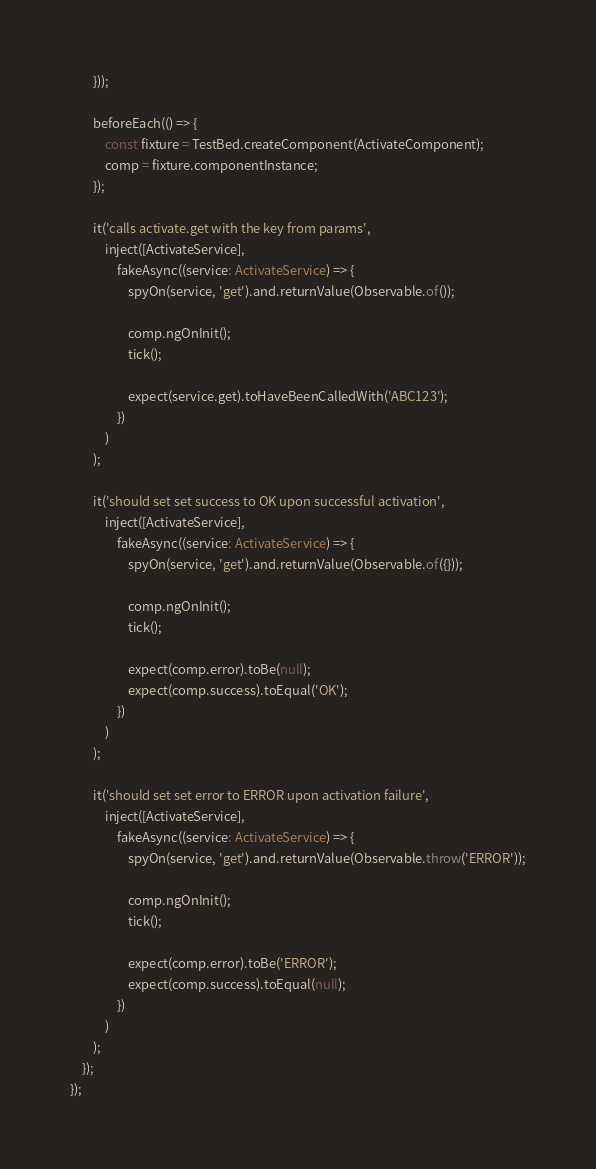<code> <loc_0><loc_0><loc_500><loc_500><_TypeScript_>        }));

        beforeEach(() => {
            const fixture = TestBed.createComponent(ActivateComponent);
            comp = fixture.componentInstance;
        });

        it('calls activate.get with the key from params',
            inject([ActivateService],
                fakeAsync((service: ActivateService) => {
                    spyOn(service, 'get').and.returnValue(Observable.of());

                    comp.ngOnInit();
                    tick();

                    expect(service.get).toHaveBeenCalledWith('ABC123');
                })
            )
        );

        it('should set set success to OK upon successful activation',
            inject([ActivateService],
                fakeAsync((service: ActivateService) => {
                    spyOn(service, 'get').and.returnValue(Observable.of({}));

                    comp.ngOnInit();
                    tick();

                    expect(comp.error).toBe(null);
                    expect(comp.success).toEqual('OK');
                })
            )
        );

        it('should set set error to ERROR upon activation failure',
            inject([ActivateService],
                fakeAsync((service: ActivateService) => {
                    spyOn(service, 'get').and.returnValue(Observable.throw('ERROR'));

                    comp.ngOnInit();
                    tick();

                    expect(comp.error).toBe('ERROR');
                    expect(comp.success).toEqual(null);
                })
            )
        );
    });
});
</code> 